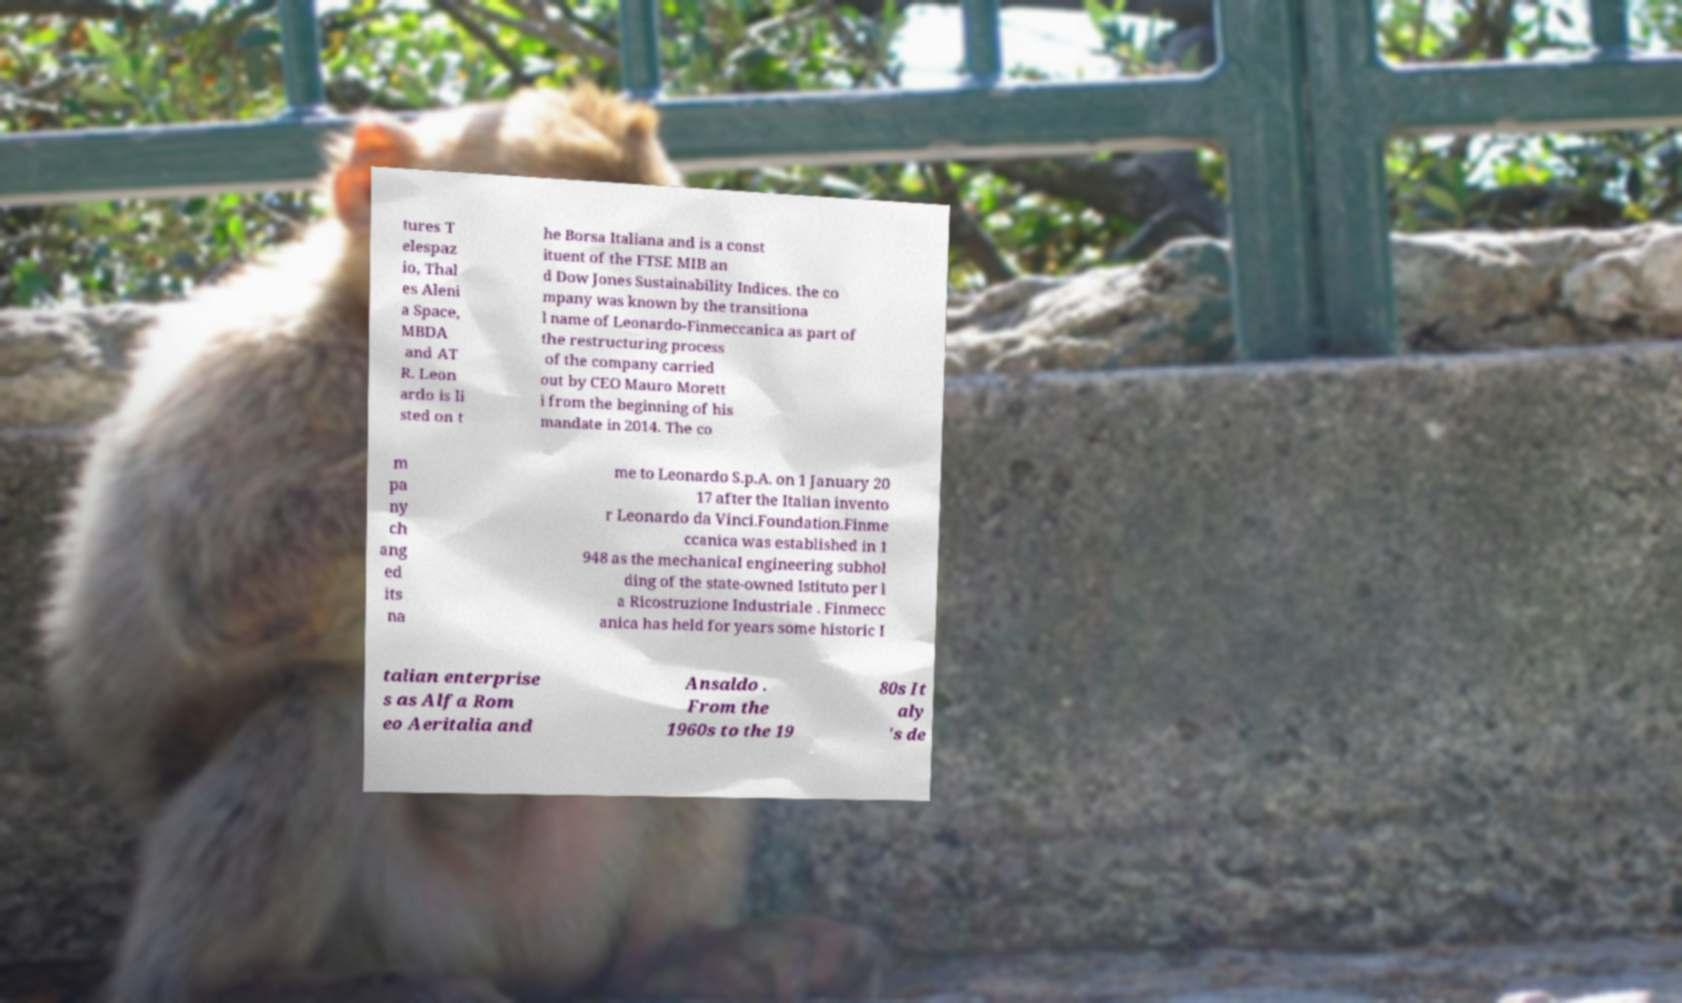I need the written content from this picture converted into text. Can you do that? tures T elespaz io, Thal es Aleni a Space, MBDA and AT R. Leon ardo is li sted on t he Borsa Italiana and is a const ituent of the FTSE MIB an d Dow Jones Sustainability Indices. the co mpany was known by the transitiona l name of Leonardo-Finmeccanica as part of the restructuring process of the company carried out by CEO Mauro Morett i from the beginning of his mandate in 2014. The co m pa ny ch ang ed its na me to Leonardo S.p.A. on 1 January 20 17 after the Italian invento r Leonardo da Vinci.Foundation.Finme ccanica was established in 1 948 as the mechanical engineering subhol ding of the state-owned Istituto per l a Ricostruzione Industriale . Finmecc anica has held for years some historic I talian enterprise s as Alfa Rom eo Aeritalia and Ansaldo . From the 1960s to the 19 80s It aly 's de 